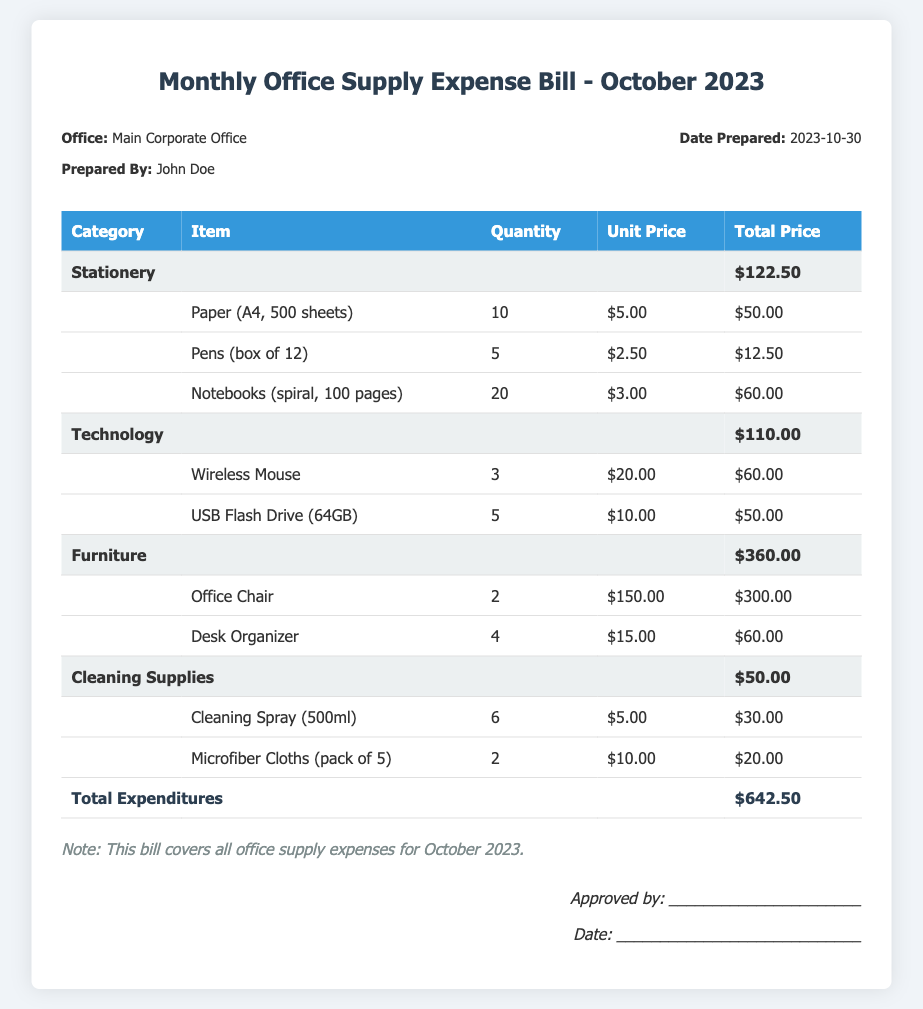What is the total expenditure for October 2023? The total expenditure can be found in the last row of the table, which sums up all the categorized expenses.
Answer: $642.50 Who prepared the bill? The name of the person who prepared the bill is mentioned in the header section.
Answer: John Doe How many Office Chairs were purchased? The quantity of Office Chairs purchased can be found in the Furniture category under the item description.
Answer: 2 What category has the highest expense? By comparing the total prices listed for each category, the highest expense category can be identified.
Answer: Furniture What is the date the bill was prepared? The date prepared is stated in the header section of the document.
Answer: 2023-10-30 How much did the USB Flash Drives cost in total? The total price for the USB Flash Drives can be calculated from the item details under the Technology category.
Answer: $50.00 How many packages of Microfiber Cloths were ordered? The quantity for Microfiber Cloths can be found in the Cleaning Supplies category.
Answer: 2 What is the total price of all items in the Stationery category? The total for the Stationery category is provided in the summary row for that category.
Answer: $122.50 What type of cleaning spray was included in the bill? The specific item listed under Cleaning Supplies provides details on the cleaning spray included.
Answer: Cleaning Spray (500ml) 